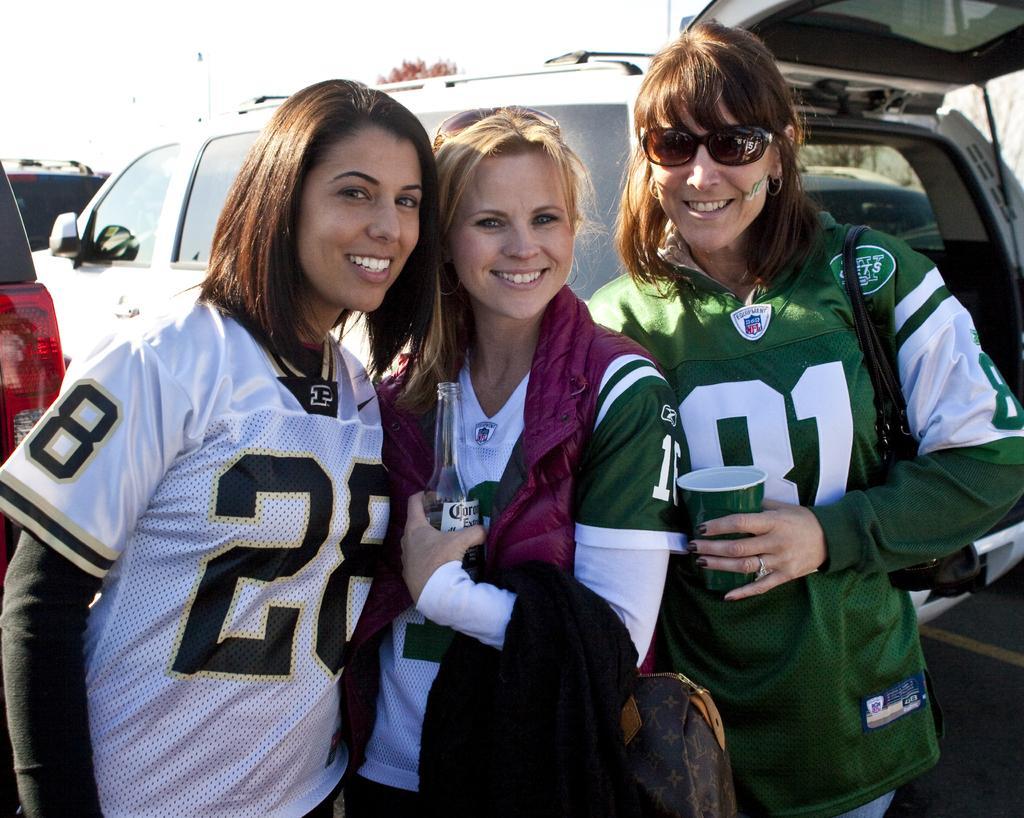How would you summarize this image in a sentence or two? In this image we can see three lady persons two were wearing green color dress, one is wearing white color dress and persons wearing green color dress carrying bags holding some cups and bottles in their hands and in the background of the image there are some cars. 